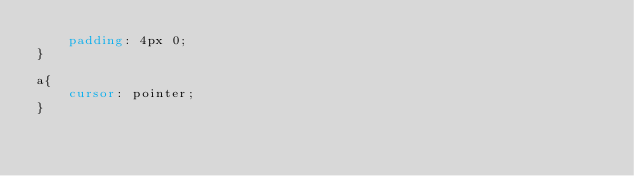Convert code to text. <code><loc_0><loc_0><loc_500><loc_500><_CSS_>    padding: 4px 0;
}

a{
    cursor: pointer;
}
</code> 